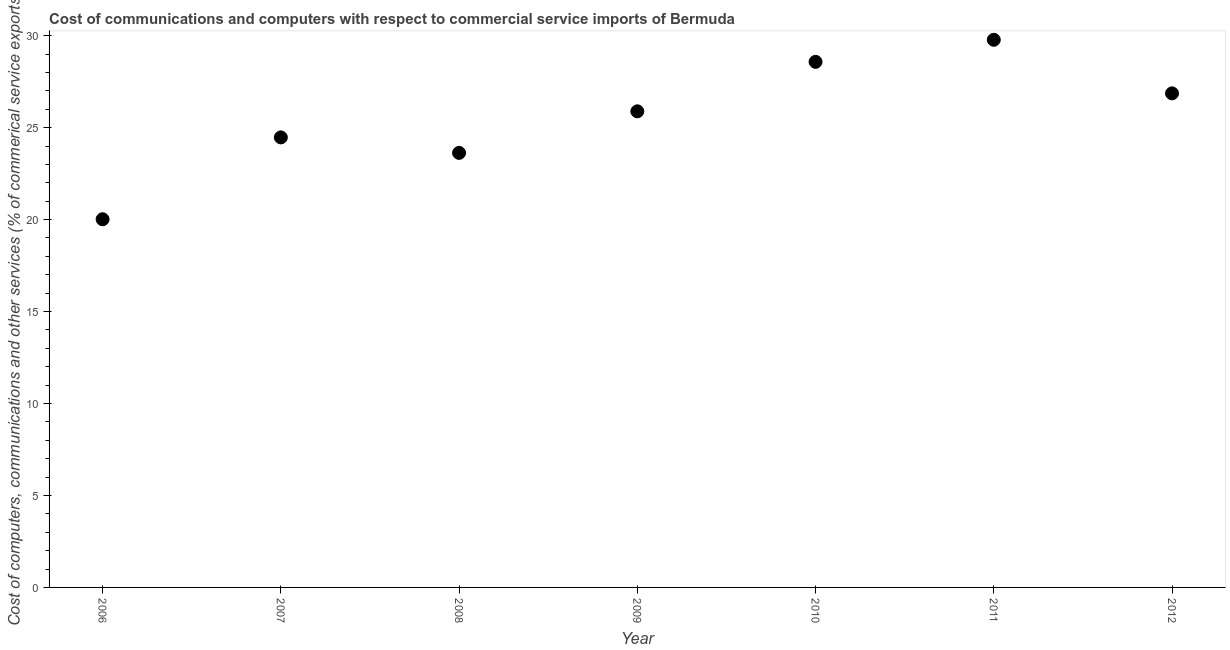What is the  computer and other services in 2006?
Your response must be concise. 20.02. Across all years, what is the maximum  computer and other services?
Offer a terse response. 29.78. Across all years, what is the minimum cost of communications?
Ensure brevity in your answer.  20.02. In which year was the cost of communications minimum?
Provide a succinct answer. 2006. What is the sum of the  computer and other services?
Give a very brief answer. 179.22. What is the difference between the cost of communications in 2010 and 2012?
Keep it short and to the point. 1.71. What is the average cost of communications per year?
Provide a succinct answer. 25.6. What is the median  computer and other services?
Keep it short and to the point. 25.89. Do a majority of the years between 2006 and 2008 (inclusive) have cost of communications greater than 29 %?
Your answer should be very brief. No. What is the ratio of the cost of communications in 2007 to that in 2009?
Offer a terse response. 0.95. Is the cost of communications in 2010 less than that in 2011?
Provide a short and direct response. Yes. What is the difference between the highest and the second highest  computer and other services?
Ensure brevity in your answer.  1.2. What is the difference between the highest and the lowest cost of communications?
Your answer should be compact. 9.76. Does the  computer and other services monotonically increase over the years?
Provide a short and direct response. No. How many dotlines are there?
Your answer should be very brief. 1. What is the difference between two consecutive major ticks on the Y-axis?
Keep it short and to the point. 5. Does the graph contain any zero values?
Your answer should be very brief. No. Does the graph contain grids?
Make the answer very short. No. What is the title of the graph?
Your answer should be compact. Cost of communications and computers with respect to commercial service imports of Bermuda. What is the label or title of the Y-axis?
Your response must be concise. Cost of computers, communications and other services (% of commerical service exports). What is the Cost of computers, communications and other services (% of commerical service exports) in 2006?
Offer a terse response. 20.02. What is the Cost of computers, communications and other services (% of commerical service exports) in 2007?
Your response must be concise. 24.47. What is the Cost of computers, communications and other services (% of commerical service exports) in 2008?
Provide a succinct answer. 23.63. What is the Cost of computers, communications and other services (% of commerical service exports) in 2009?
Provide a succinct answer. 25.89. What is the Cost of computers, communications and other services (% of commerical service exports) in 2010?
Your answer should be compact. 28.58. What is the Cost of computers, communications and other services (% of commerical service exports) in 2011?
Provide a short and direct response. 29.78. What is the Cost of computers, communications and other services (% of commerical service exports) in 2012?
Provide a short and direct response. 26.86. What is the difference between the Cost of computers, communications and other services (% of commerical service exports) in 2006 and 2007?
Offer a very short reply. -4.45. What is the difference between the Cost of computers, communications and other services (% of commerical service exports) in 2006 and 2008?
Keep it short and to the point. -3.61. What is the difference between the Cost of computers, communications and other services (% of commerical service exports) in 2006 and 2009?
Ensure brevity in your answer.  -5.87. What is the difference between the Cost of computers, communications and other services (% of commerical service exports) in 2006 and 2010?
Your response must be concise. -8.56. What is the difference between the Cost of computers, communications and other services (% of commerical service exports) in 2006 and 2011?
Provide a short and direct response. -9.76. What is the difference between the Cost of computers, communications and other services (% of commerical service exports) in 2006 and 2012?
Your answer should be very brief. -6.84. What is the difference between the Cost of computers, communications and other services (% of commerical service exports) in 2007 and 2008?
Ensure brevity in your answer.  0.84. What is the difference between the Cost of computers, communications and other services (% of commerical service exports) in 2007 and 2009?
Make the answer very short. -1.42. What is the difference between the Cost of computers, communications and other services (% of commerical service exports) in 2007 and 2010?
Make the answer very short. -4.11. What is the difference between the Cost of computers, communications and other services (% of commerical service exports) in 2007 and 2011?
Ensure brevity in your answer.  -5.31. What is the difference between the Cost of computers, communications and other services (% of commerical service exports) in 2007 and 2012?
Keep it short and to the point. -2.39. What is the difference between the Cost of computers, communications and other services (% of commerical service exports) in 2008 and 2009?
Give a very brief answer. -2.26. What is the difference between the Cost of computers, communications and other services (% of commerical service exports) in 2008 and 2010?
Your answer should be compact. -4.95. What is the difference between the Cost of computers, communications and other services (% of commerical service exports) in 2008 and 2011?
Make the answer very short. -6.15. What is the difference between the Cost of computers, communications and other services (% of commerical service exports) in 2008 and 2012?
Keep it short and to the point. -3.24. What is the difference between the Cost of computers, communications and other services (% of commerical service exports) in 2009 and 2010?
Your answer should be compact. -2.69. What is the difference between the Cost of computers, communications and other services (% of commerical service exports) in 2009 and 2011?
Offer a terse response. -3.89. What is the difference between the Cost of computers, communications and other services (% of commerical service exports) in 2009 and 2012?
Your response must be concise. -0.98. What is the difference between the Cost of computers, communications and other services (% of commerical service exports) in 2010 and 2011?
Provide a succinct answer. -1.2. What is the difference between the Cost of computers, communications and other services (% of commerical service exports) in 2010 and 2012?
Keep it short and to the point. 1.71. What is the difference between the Cost of computers, communications and other services (% of commerical service exports) in 2011 and 2012?
Ensure brevity in your answer.  2.91. What is the ratio of the Cost of computers, communications and other services (% of commerical service exports) in 2006 to that in 2007?
Provide a succinct answer. 0.82. What is the ratio of the Cost of computers, communications and other services (% of commerical service exports) in 2006 to that in 2008?
Offer a terse response. 0.85. What is the ratio of the Cost of computers, communications and other services (% of commerical service exports) in 2006 to that in 2009?
Your answer should be very brief. 0.77. What is the ratio of the Cost of computers, communications and other services (% of commerical service exports) in 2006 to that in 2010?
Provide a short and direct response. 0.7. What is the ratio of the Cost of computers, communications and other services (% of commerical service exports) in 2006 to that in 2011?
Make the answer very short. 0.67. What is the ratio of the Cost of computers, communications and other services (% of commerical service exports) in 2006 to that in 2012?
Keep it short and to the point. 0.74. What is the ratio of the Cost of computers, communications and other services (% of commerical service exports) in 2007 to that in 2008?
Offer a terse response. 1.04. What is the ratio of the Cost of computers, communications and other services (% of commerical service exports) in 2007 to that in 2009?
Give a very brief answer. 0.94. What is the ratio of the Cost of computers, communications and other services (% of commerical service exports) in 2007 to that in 2010?
Ensure brevity in your answer.  0.86. What is the ratio of the Cost of computers, communications and other services (% of commerical service exports) in 2007 to that in 2011?
Provide a succinct answer. 0.82. What is the ratio of the Cost of computers, communications and other services (% of commerical service exports) in 2007 to that in 2012?
Your answer should be very brief. 0.91. What is the ratio of the Cost of computers, communications and other services (% of commerical service exports) in 2008 to that in 2009?
Your answer should be very brief. 0.91. What is the ratio of the Cost of computers, communications and other services (% of commerical service exports) in 2008 to that in 2010?
Make the answer very short. 0.83. What is the ratio of the Cost of computers, communications and other services (% of commerical service exports) in 2008 to that in 2011?
Ensure brevity in your answer.  0.79. What is the ratio of the Cost of computers, communications and other services (% of commerical service exports) in 2008 to that in 2012?
Provide a succinct answer. 0.88. What is the ratio of the Cost of computers, communications and other services (% of commerical service exports) in 2009 to that in 2010?
Offer a terse response. 0.91. What is the ratio of the Cost of computers, communications and other services (% of commerical service exports) in 2009 to that in 2011?
Ensure brevity in your answer.  0.87. What is the ratio of the Cost of computers, communications and other services (% of commerical service exports) in 2009 to that in 2012?
Your answer should be compact. 0.96. What is the ratio of the Cost of computers, communications and other services (% of commerical service exports) in 2010 to that in 2012?
Provide a short and direct response. 1.06. What is the ratio of the Cost of computers, communications and other services (% of commerical service exports) in 2011 to that in 2012?
Your response must be concise. 1.11. 